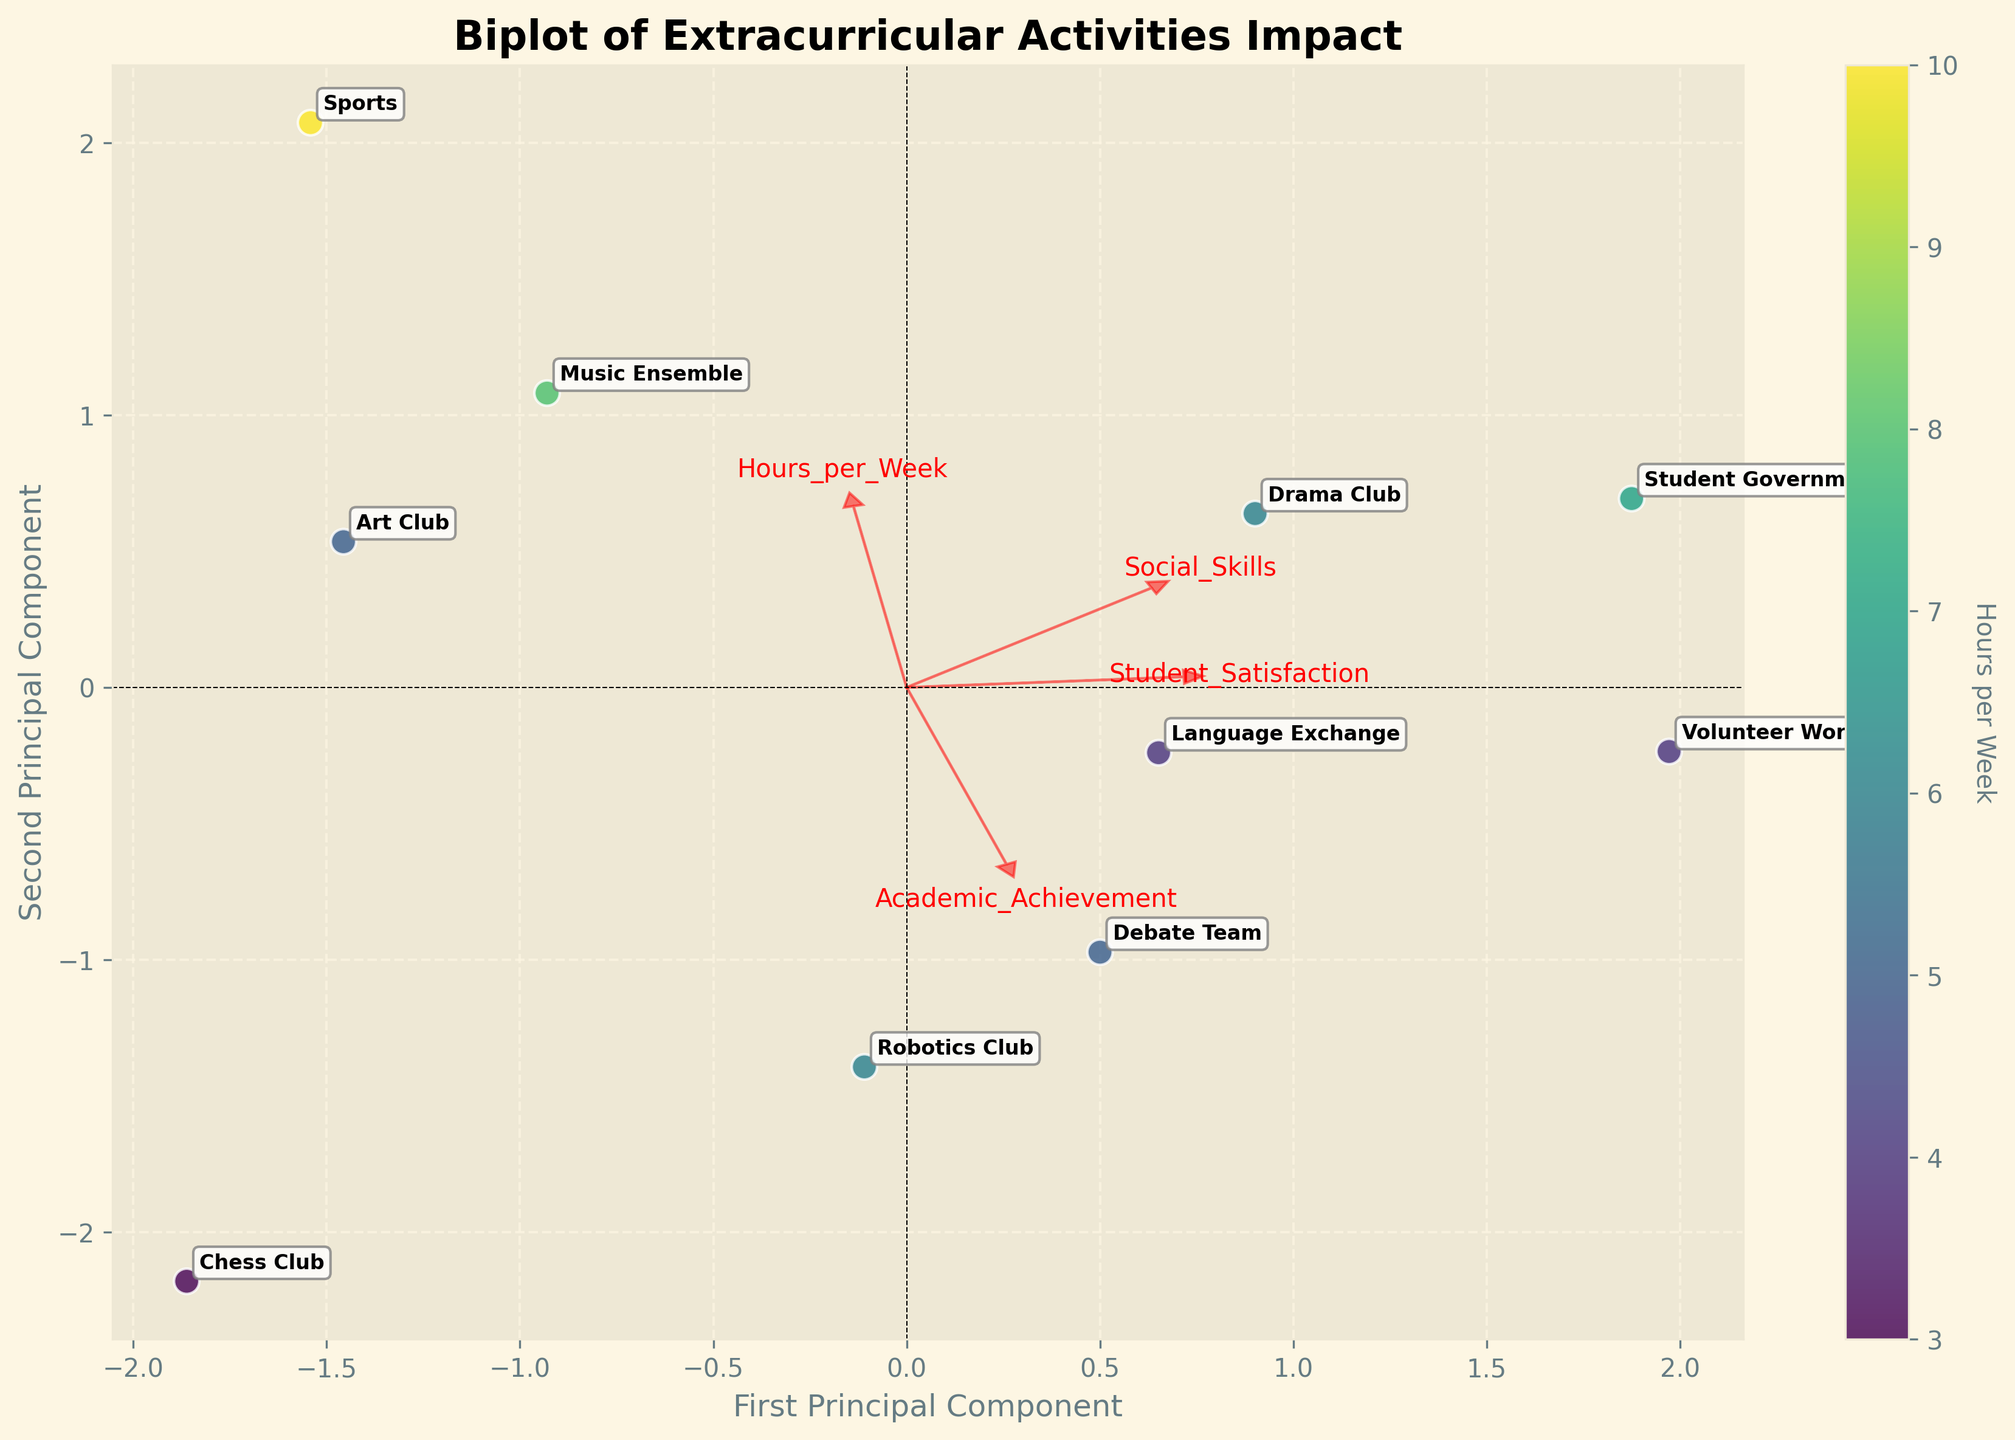What is the title of the figure? The title is at the top of the plot, usually a brief summary of what the figure represents. Here, it states the main subject of the data plotted.
Answer: Biplot of Extracurricular Activities Impact How many unique extracurricular activities are represented in the plot? Each activity is shown as a distinct data point in the scatter plot, with labels indicating their names. Counting these labels gives us the number of unique activities.
Answer: 10 What colors are used to represent different "Hours per Week" in the plot? The color gradient, visible through the scatter plot points and the colorbar, ranges from lighter to darker shades. The exact spectrum used is viridis, which includes a range from yellow to blue-green.
Answer: Yellow to blue-green Which activity has the highest Academic Achievement score based on the plot? Looking for the point farthest along the Academic Achievement vector helps identify the activity with the highest score. The label on this point gives the specific activity name.
Answer: Robotics Club Which activity appears to balance well between Academic Achievement and Social Skills? This requires identifying a point that is midway between the vectors for Academic Achievement and Social Skills on the plot. This point should ideally have good values on both components.
Answer: Debate Team or Volunteer Work (Both are close to being balanced) What is the relationship between "Hours per Week" and "Social Skills"? Observing the gradient on the scatter plot helps determine if there is a visible trend between the color (representing Hours per Week) and the location on the Social Skills axis.
Answer: Often, activities with higher Social Skills scores tend to have fewer hours per week Is there any activity with lower Student Satisfaction but high Academic Achievement? Find the points with low values on the Student Satisfaction vector and check their positions relative to the Academic Achievement vector.
Answer: Chess Club (relatively lower Student Satisfaction but still high Academic Achievement) Which activity has the highest score for Social Skills, and how does it rank in Academic Achievement? Identify the activity at the tip of the Social Skills vector, then check its corresponding position relative to the Academic Achievement vector.
Answer: Student Government (high in both Social Skills and Academic Achievement) Do more hours per week correlate with higher or lower social skills development? The scatter plot allows for visualization of the relationship by the intensity of the colors (more hours per week). Keeping an eye on the Social Skills vector tells if there’s a correlation.
Answer: Generally, more hours per week correlate with higher social skills development Which two activities are the closest to each other in the biplot, and do they share similar traits? Comparing the positions of the data points and identifying the closest pair gives the activities. Then, review if they are similar in terms of hours per week, satisfaction, etc.
Answer: Drama Club and Robotics Club (close together, potentially similar traits based on plot proximity) 